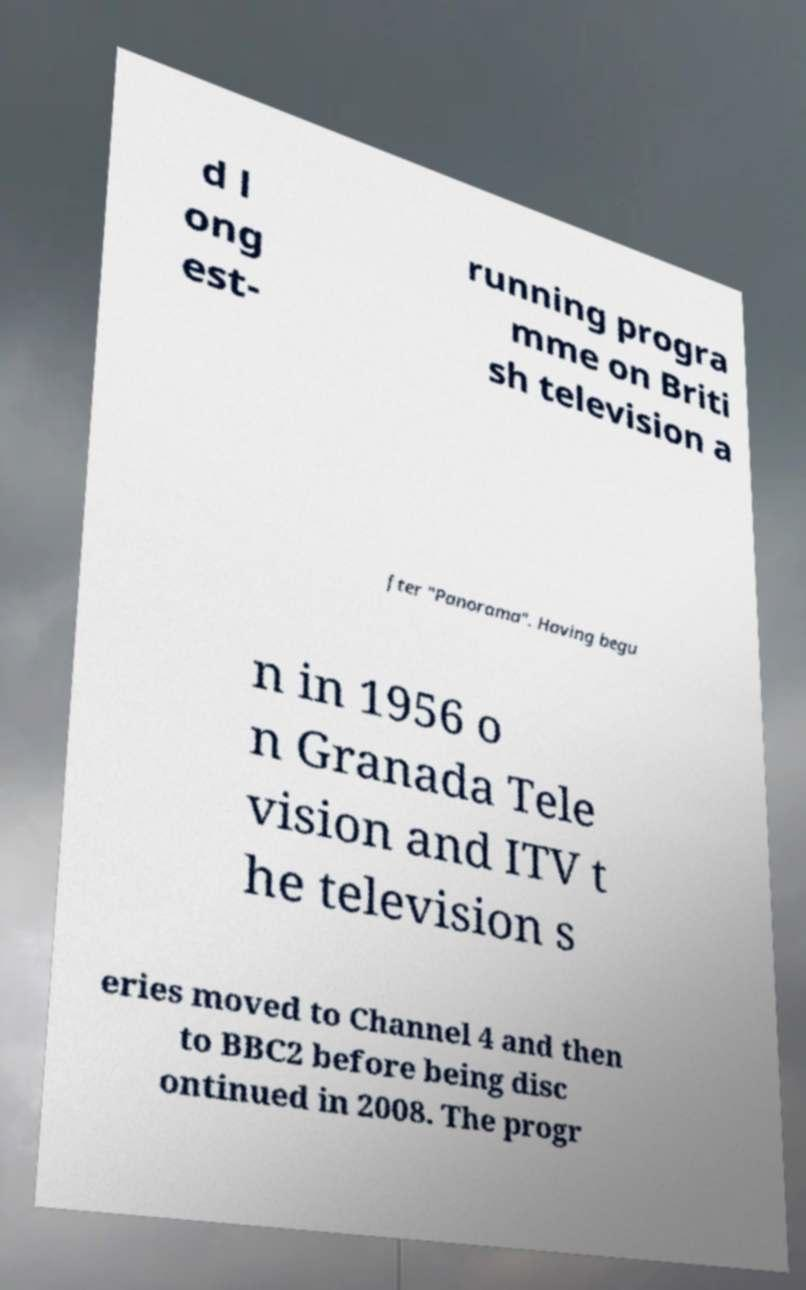I need the written content from this picture converted into text. Can you do that? d l ong est- running progra mme on Briti sh television a fter "Panorama". Having begu n in 1956 o n Granada Tele vision and ITV t he television s eries moved to Channel 4 and then to BBC2 before being disc ontinued in 2008. The progr 